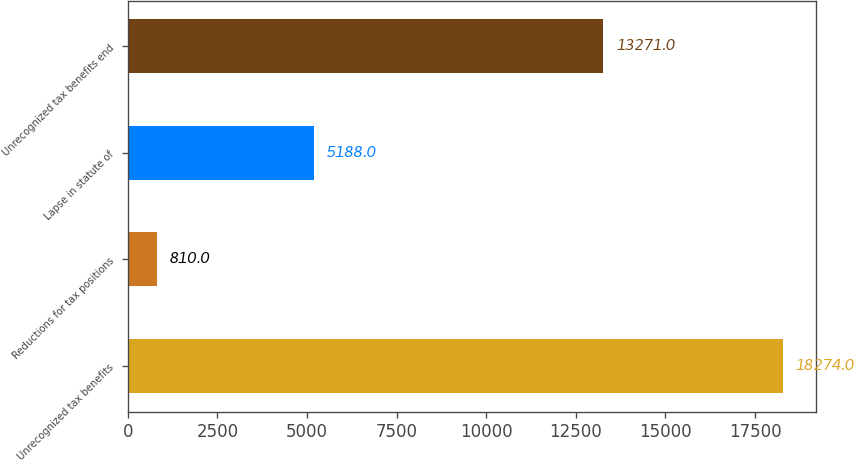<chart> <loc_0><loc_0><loc_500><loc_500><bar_chart><fcel>Unrecognized tax benefits<fcel>Reductions for tax positions<fcel>Lapse in statute of<fcel>Unrecognized tax benefits end<nl><fcel>18274<fcel>810<fcel>5188<fcel>13271<nl></chart> 